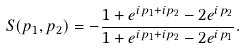<formula> <loc_0><loc_0><loc_500><loc_500>S ( p _ { 1 } , p _ { 2 } ) = - \frac { 1 + e ^ { i p _ { 1 } + i p _ { 2 } } - 2 e ^ { i p _ { 2 } } } { 1 + e ^ { i p _ { 1 } + i p _ { 2 } } - 2 e ^ { i p _ { 1 } } } .</formula> 